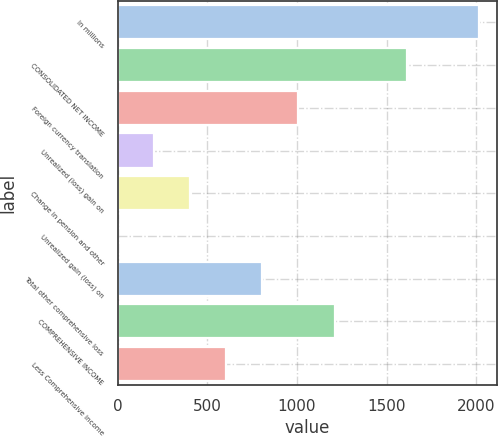<chart> <loc_0><loc_0><loc_500><loc_500><bar_chart><fcel>In millions<fcel>CONSOLIDATED NET INCOME<fcel>Foreign currency translation<fcel>Unrealized (loss) gain on<fcel>Change in pension and other<fcel>Unrealized gain (loss) on<fcel>Total other comprehensive loss<fcel>COMPREHENSIVE INCOME<fcel>Less Comprehensive income<nl><fcel>2015<fcel>1612.2<fcel>1008<fcel>202.4<fcel>403.8<fcel>1<fcel>806.6<fcel>1209.4<fcel>605.2<nl></chart> 